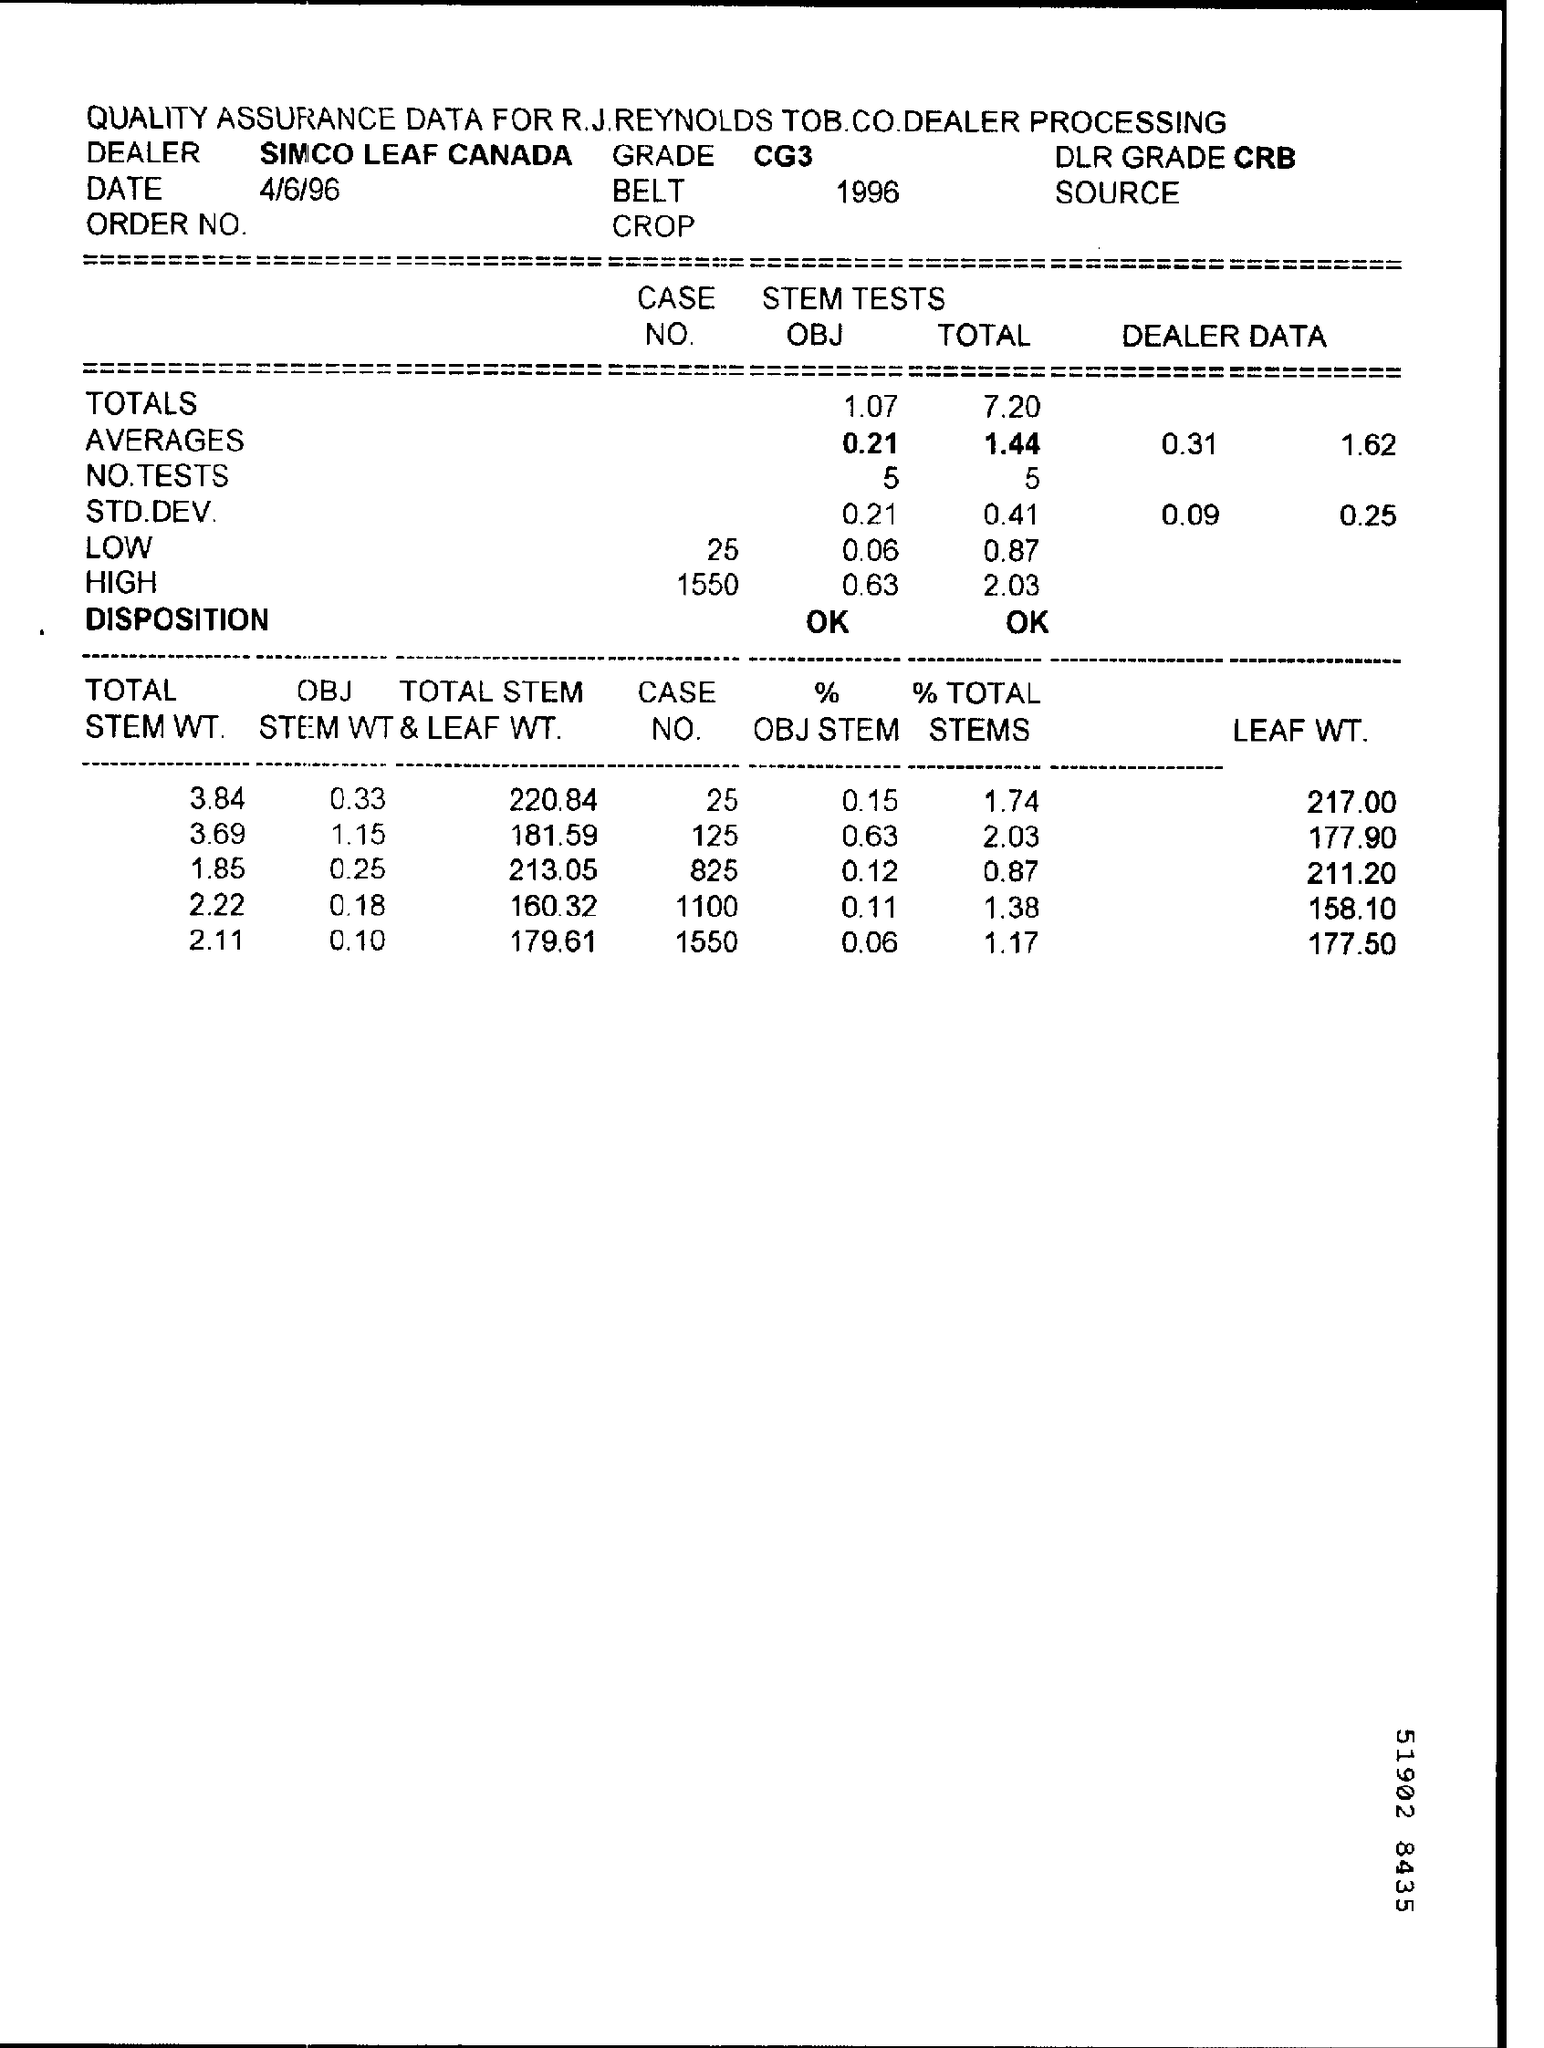Indicate a few pertinent items in this graphic. The information written in the Grade Field is CG3. The memorandum is dated on April 6, 1996. 